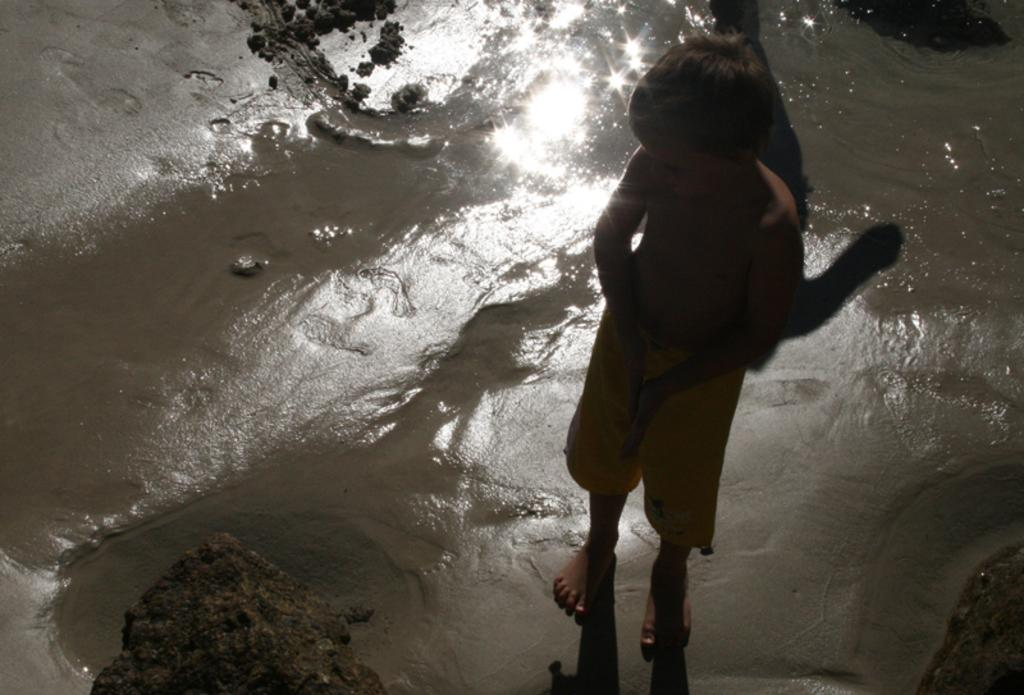Who is the main subject in the image? There is a boy in the image. What is the boy standing on? The boy is standing on the sand. What can be seen behind the boy? There is water visible behind the boy. What is in front of the boy? There appears to be a rock in front of the boy. What invention is the boy holding in his hand in the image? There is no invention visible in the boy's hand in the image. Can you tell me how many drawers are present in the image? There are no drawers present in the image. 